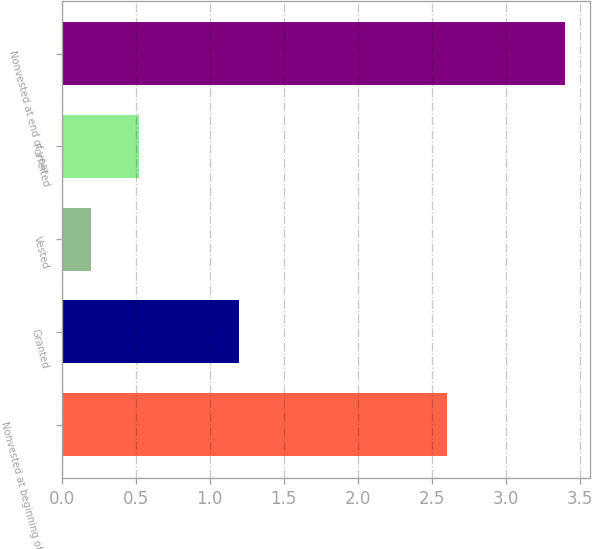Convert chart. <chart><loc_0><loc_0><loc_500><loc_500><bar_chart><fcel>Nonvested at beginning of year<fcel>Granted<fcel>Vested<fcel>Forfeited<fcel>Nonvested at end of year<nl><fcel>2.6<fcel>1.2<fcel>0.2<fcel>0.52<fcel>3.4<nl></chart> 